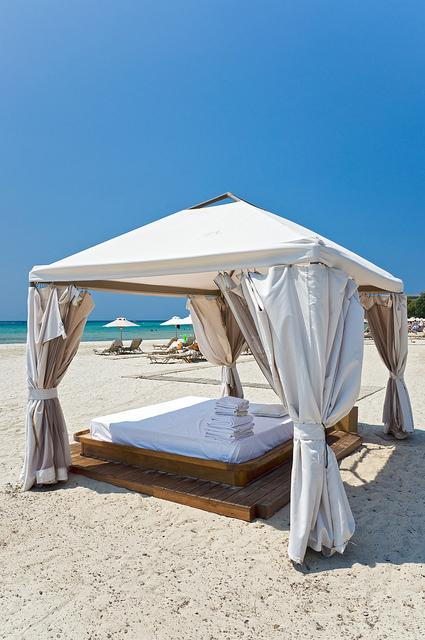What will this tent offer protection from?

Choices:
A) tsunami
B) insects
C) gangs
D) sun sun 